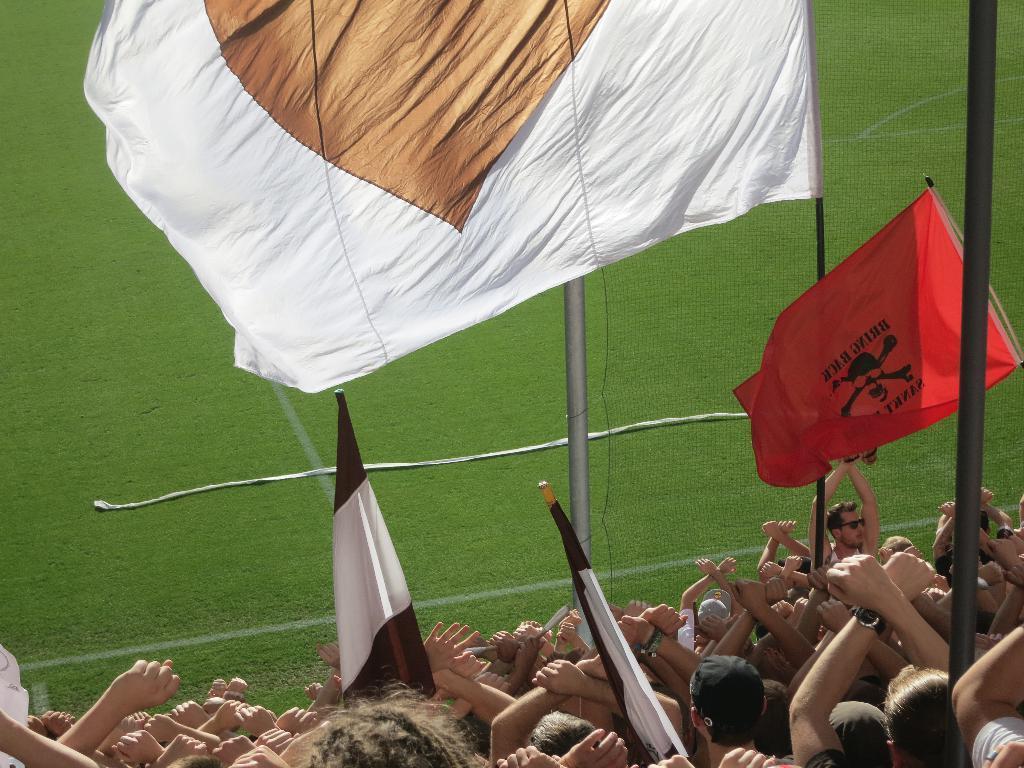How would you summarize this image in a sentence or two? In this image in front there are people holding the flags. There are poles. At the bottom of the image there is grass on the surface. 